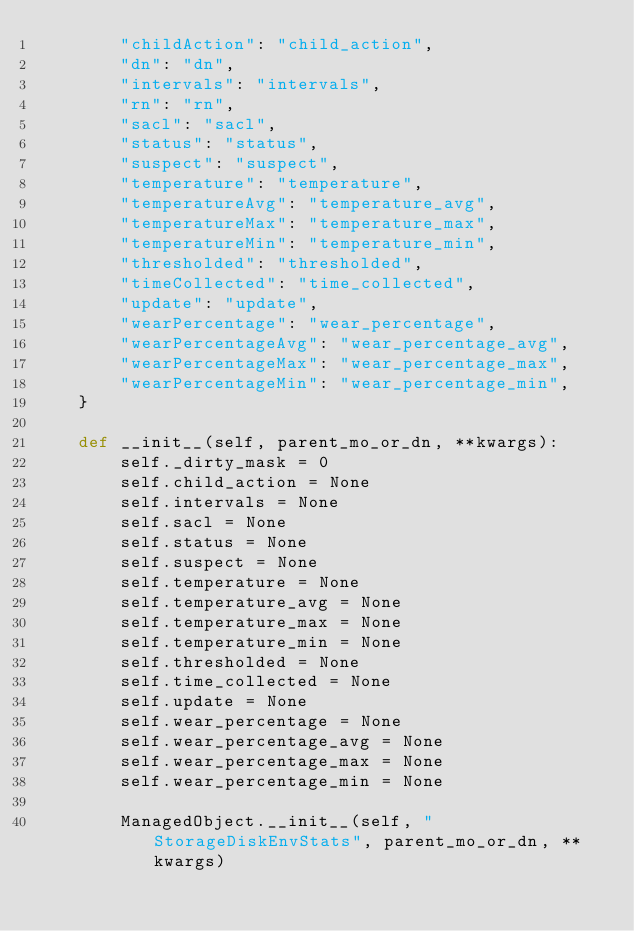<code> <loc_0><loc_0><loc_500><loc_500><_Python_>        "childAction": "child_action", 
        "dn": "dn", 
        "intervals": "intervals", 
        "rn": "rn", 
        "sacl": "sacl", 
        "status": "status", 
        "suspect": "suspect", 
        "temperature": "temperature", 
        "temperatureAvg": "temperature_avg", 
        "temperatureMax": "temperature_max", 
        "temperatureMin": "temperature_min", 
        "thresholded": "thresholded", 
        "timeCollected": "time_collected", 
        "update": "update", 
        "wearPercentage": "wear_percentage", 
        "wearPercentageAvg": "wear_percentage_avg", 
        "wearPercentageMax": "wear_percentage_max", 
        "wearPercentageMin": "wear_percentage_min", 
    }

    def __init__(self, parent_mo_or_dn, **kwargs):
        self._dirty_mask = 0
        self.child_action = None
        self.intervals = None
        self.sacl = None
        self.status = None
        self.suspect = None
        self.temperature = None
        self.temperature_avg = None
        self.temperature_max = None
        self.temperature_min = None
        self.thresholded = None
        self.time_collected = None
        self.update = None
        self.wear_percentage = None
        self.wear_percentage_avg = None
        self.wear_percentage_max = None
        self.wear_percentage_min = None

        ManagedObject.__init__(self, "StorageDiskEnvStats", parent_mo_or_dn, **kwargs)
</code> 